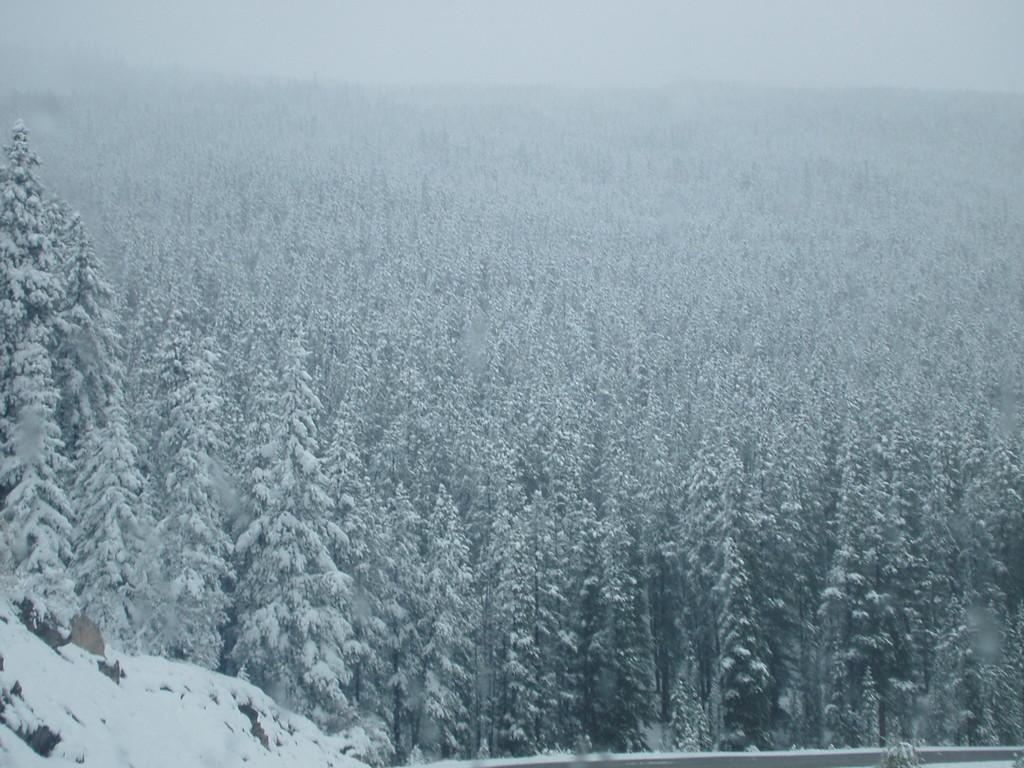What type of view is shown in the image? The image is an outside view. What can be seen in the image besides the outside view? There are many trees in the image. What is the condition of the trees in the image? The trees are covered with snow. What type of notebook is visible in the image? There is no notebook present in the image. What is the relation between the trees and the downtown area in the image? There is no downtown area mentioned in the image, and the trees are not in relation to any specific area. 